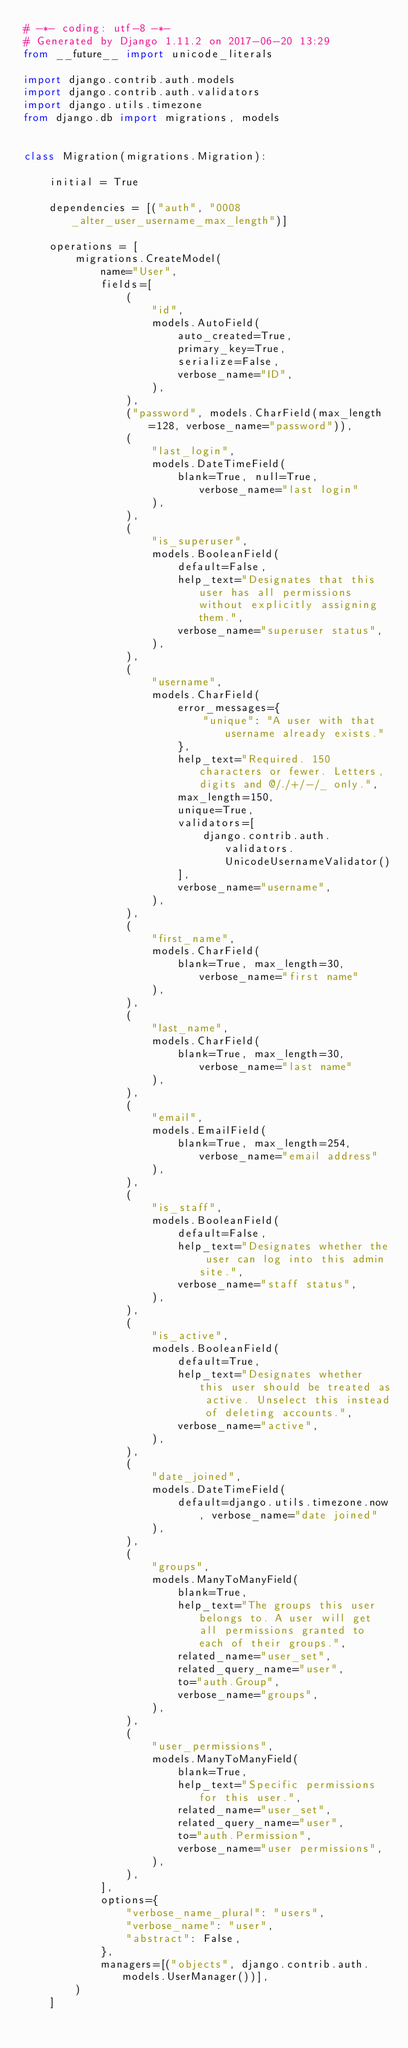<code> <loc_0><loc_0><loc_500><loc_500><_Python_># -*- coding: utf-8 -*-
# Generated by Django 1.11.2 on 2017-06-20 13:29
from __future__ import unicode_literals

import django.contrib.auth.models
import django.contrib.auth.validators
import django.utils.timezone
from django.db import migrations, models


class Migration(migrations.Migration):

    initial = True

    dependencies = [("auth", "0008_alter_user_username_max_length")]

    operations = [
        migrations.CreateModel(
            name="User",
            fields=[
                (
                    "id",
                    models.AutoField(
                        auto_created=True,
                        primary_key=True,
                        serialize=False,
                        verbose_name="ID",
                    ),
                ),
                ("password", models.CharField(max_length=128, verbose_name="password")),
                (
                    "last_login",
                    models.DateTimeField(
                        blank=True, null=True, verbose_name="last login"
                    ),
                ),
                (
                    "is_superuser",
                    models.BooleanField(
                        default=False,
                        help_text="Designates that this user has all permissions without explicitly assigning them.",
                        verbose_name="superuser status",
                    ),
                ),
                (
                    "username",
                    models.CharField(
                        error_messages={
                            "unique": "A user with that username already exists."
                        },
                        help_text="Required. 150 characters or fewer. Letters, digits and @/./+/-/_ only.",
                        max_length=150,
                        unique=True,
                        validators=[
                            django.contrib.auth.validators.UnicodeUsernameValidator()
                        ],
                        verbose_name="username",
                    ),
                ),
                (
                    "first_name",
                    models.CharField(
                        blank=True, max_length=30, verbose_name="first name"
                    ),
                ),
                (
                    "last_name",
                    models.CharField(
                        blank=True, max_length=30, verbose_name="last name"
                    ),
                ),
                (
                    "email",
                    models.EmailField(
                        blank=True, max_length=254, verbose_name="email address"
                    ),
                ),
                (
                    "is_staff",
                    models.BooleanField(
                        default=False,
                        help_text="Designates whether the user can log into this admin site.",
                        verbose_name="staff status",
                    ),
                ),
                (
                    "is_active",
                    models.BooleanField(
                        default=True,
                        help_text="Designates whether this user should be treated as active. Unselect this instead of deleting accounts.",
                        verbose_name="active",
                    ),
                ),
                (
                    "date_joined",
                    models.DateTimeField(
                        default=django.utils.timezone.now, verbose_name="date joined"
                    ),
                ),
                (
                    "groups",
                    models.ManyToManyField(
                        blank=True,
                        help_text="The groups this user belongs to. A user will get all permissions granted to each of their groups.",
                        related_name="user_set",
                        related_query_name="user",
                        to="auth.Group",
                        verbose_name="groups",
                    ),
                ),
                (
                    "user_permissions",
                    models.ManyToManyField(
                        blank=True,
                        help_text="Specific permissions for this user.",
                        related_name="user_set",
                        related_query_name="user",
                        to="auth.Permission",
                        verbose_name="user permissions",
                    ),
                ),
            ],
            options={
                "verbose_name_plural": "users",
                "verbose_name": "user",
                "abstract": False,
            },
            managers=[("objects", django.contrib.auth.models.UserManager())],
        )
    ]
</code> 